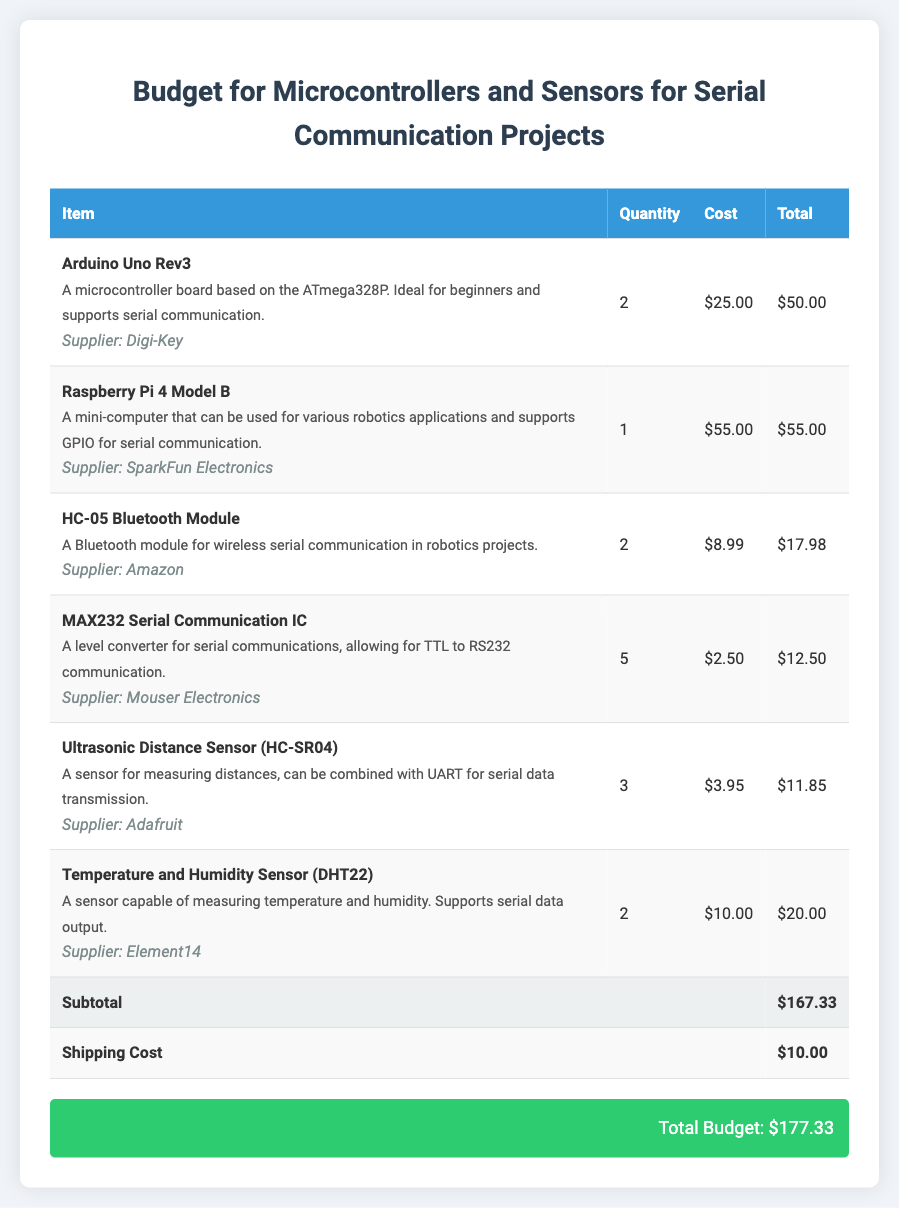What is the total budget? The total budget is listed in the summary at the bottom of the document, which is calculated including shipping costs.
Answer: $177.33 How many Arduino Uno Rev3 boards are needed? The quantity for Arduino Uno Rev3 is specified in the table, which states there are 2 boards required.
Answer: 2 What is the cost of one Raspberry Pi 4 Model B? The document lists the price per unit for Raspberry Pi 4 Model B in the cost column of the table, which is $55.00.
Answer: $55.00 What type of sensor is the HC-SR04? The document describes HC-SR04 as an ultrasonic distance sensor used for measuring distances.
Answer: Ultrasonic Distance Sensor Which supplier provides the DHT22 sensor? The supplier information for DHT22 is found in the item description within the table, which names Element14.
Answer: Element14 How many MAX232 Serial Communication ICs are included in the budget? The quantity of MAX232 Serial Communication ICs is indicated in the table, which shows a total of 5 ICs.
Answer: 5 What is the subtotal before shipping costs? The subtotal is displayed in the table, calculated before adding the shipping fee, which is $167.33.
Answer: $167.33 What is the shipping cost for the budget? The document specifies the shipping cost in the table, which is listed as $10.00.
Answer: $10.00 